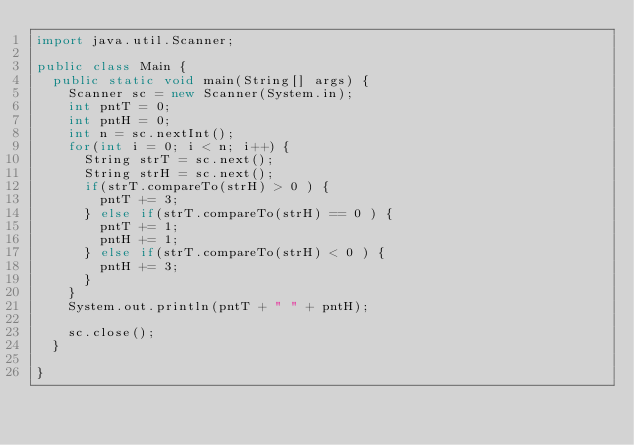Convert code to text. <code><loc_0><loc_0><loc_500><loc_500><_Java_>import java.util.Scanner;

public class Main {
	public static void main(String[] args) {
		Scanner sc = new Scanner(System.in);
		int pntT = 0;
		int pntH = 0;
		int n = sc.nextInt();
		for(int i = 0; i < n; i++) {
			String strT = sc.next();
			String strH = sc.next();
			if(strT.compareTo(strH) > 0 ) {
				pntT += 3;
			} else if(strT.compareTo(strH) == 0 ) {
				pntT += 1;
				pntH += 1;
			} else if(strT.compareTo(strH) < 0 ) {
				pntH += 3;
			}
		}
		System.out.println(pntT + " " + pntH);
		
		sc.close();
	}
	
}
</code> 